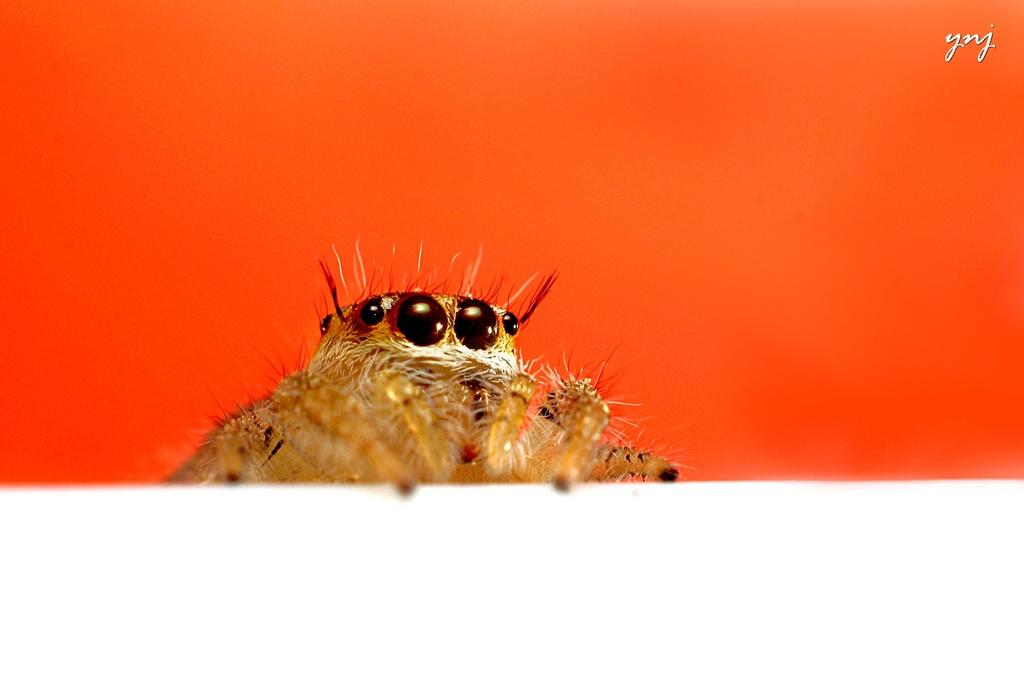What type of creature can be seen in the image? There is an animal in the image. What color is the wall behind the animal? The wall is orange in the image. What type of men can be seen feeling shame in the image? There are no men or feelings of shame present in the image; it features an animal and an orange wall. How many times does the animal bite the wall in the image? There is no indication of the animal biting the wall in the image. 